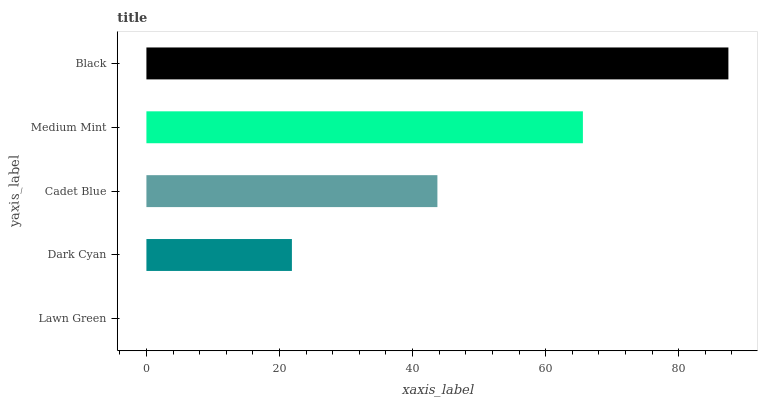Is Lawn Green the minimum?
Answer yes or no. Yes. Is Black the maximum?
Answer yes or no. Yes. Is Dark Cyan the minimum?
Answer yes or no. No. Is Dark Cyan the maximum?
Answer yes or no. No. Is Dark Cyan greater than Lawn Green?
Answer yes or no. Yes. Is Lawn Green less than Dark Cyan?
Answer yes or no. Yes. Is Lawn Green greater than Dark Cyan?
Answer yes or no. No. Is Dark Cyan less than Lawn Green?
Answer yes or no. No. Is Cadet Blue the high median?
Answer yes or no. Yes. Is Cadet Blue the low median?
Answer yes or no. Yes. Is Medium Mint the high median?
Answer yes or no. No. Is Medium Mint the low median?
Answer yes or no. No. 